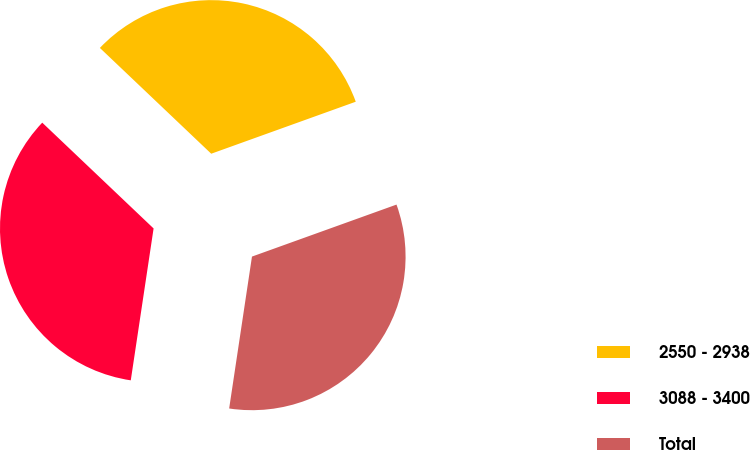<chart> <loc_0><loc_0><loc_500><loc_500><pie_chart><fcel>2550 - 2938<fcel>3088 - 3400<fcel>Total<nl><fcel>32.41%<fcel>34.72%<fcel>32.87%<nl></chart> 